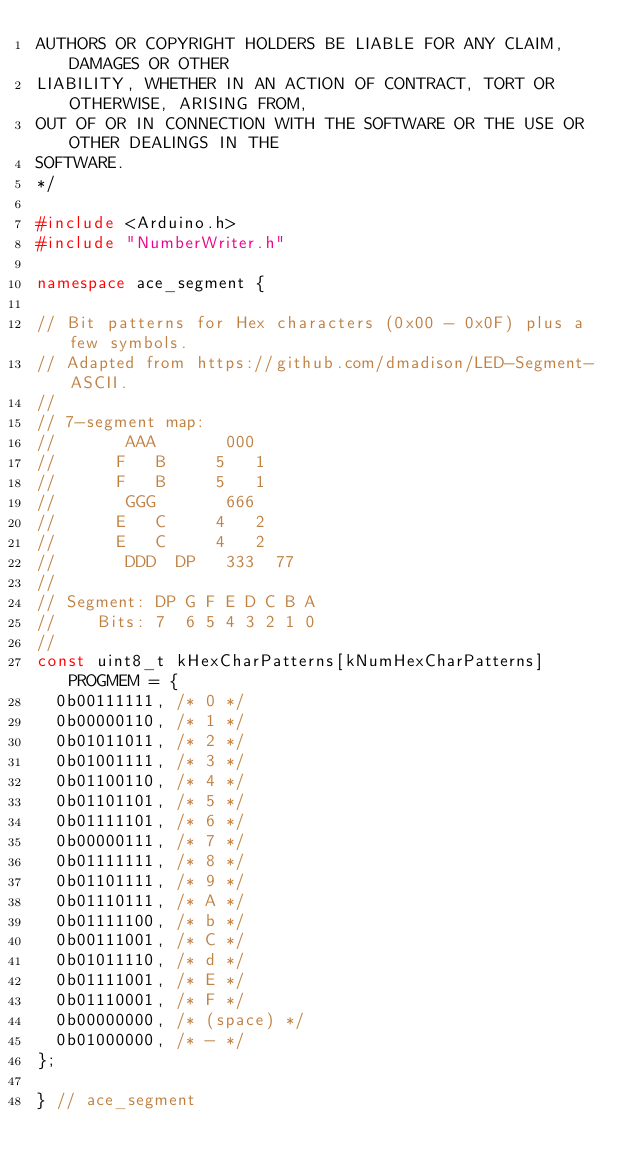<code> <loc_0><loc_0><loc_500><loc_500><_C++_>AUTHORS OR COPYRIGHT HOLDERS BE LIABLE FOR ANY CLAIM, DAMAGES OR OTHER
LIABILITY, WHETHER IN AN ACTION OF CONTRACT, TORT OR OTHERWISE, ARISING FROM,
OUT OF OR IN CONNECTION WITH THE SOFTWARE OR THE USE OR OTHER DEALINGS IN THE
SOFTWARE.
*/

#include <Arduino.h>
#include "NumberWriter.h"

namespace ace_segment {

// Bit patterns for Hex characters (0x00 - 0x0F) plus a few symbols.
// Adapted from https://github.com/dmadison/LED-Segment-ASCII.
//
// 7-segment map:
//       AAA       000
//      F   B     5   1
//      F   B     5   1
//       GGG       666
//      E   C     4   2
//      E   C     4   2
//       DDD  DP   333  77
//
// Segment: DP G F E D C B A
//    Bits: 7  6 5 4 3 2 1 0
//
const uint8_t kHexCharPatterns[kNumHexCharPatterns] PROGMEM = {
  0b00111111, /* 0 */
  0b00000110, /* 1 */
  0b01011011, /* 2 */
  0b01001111, /* 3 */
  0b01100110, /* 4 */
  0b01101101, /* 5 */
  0b01111101, /* 6 */
  0b00000111, /* 7 */
  0b01111111, /* 8 */
  0b01101111, /* 9 */
  0b01110111, /* A */
  0b01111100, /* b */
  0b00111001, /* C */
  0b01011110, /* d */
  0b01111001, /* E */
  0b01110001, /* F */
  0b00000000, /* (space) */
  0b01000000, /* - */
};

} // ace_segment
</code> 